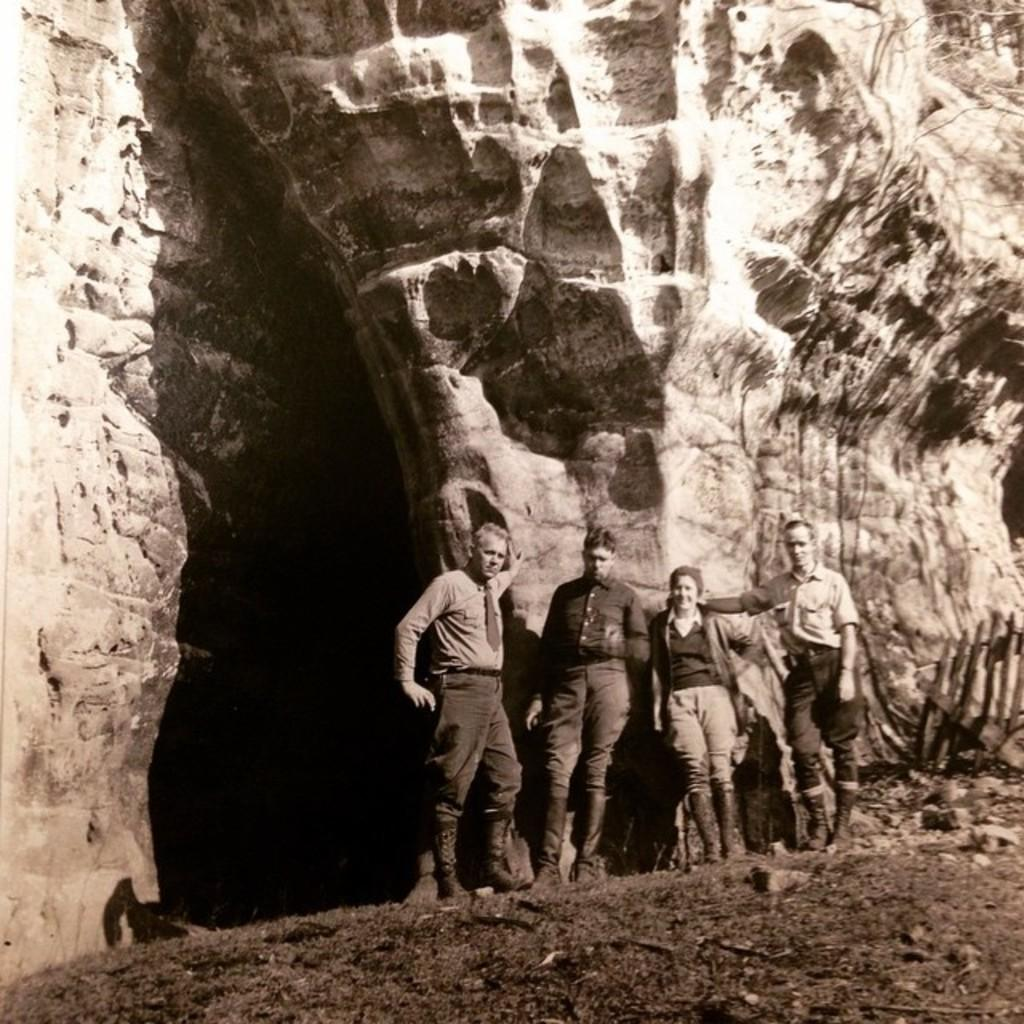What is the main feature in the image that resembles a wall? There is a huge rock shaped like a wall in the image. What other structure can be seen near the rock? There is a pillar near the rock in the image. How many people are present in the image? Four people are standing on a path in the image. What is the color scheme of the image? The image is in black and white. What type of nation is depicted in the image? There is no nation depicted in the image; it features a rock, a pillar, and four people standing on a path. How many pigs can be seen interacting with the rock in the image? There are no pigs present in the image. 